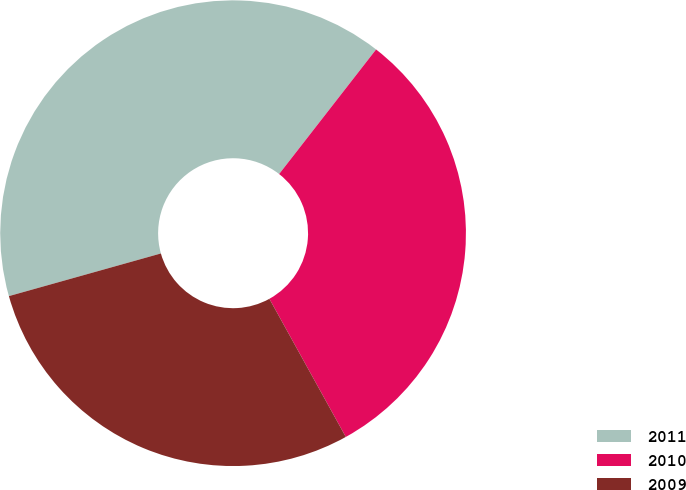Convert chart to OTSL. <chart><loc_0><loc_0><loc_500><loc_500><pie_chart><fcel>2011<fcel>2010<fcel>2009<nl><fcel>39.88%<fcel>31.43%<fcel>28.69%<nl></chart> 